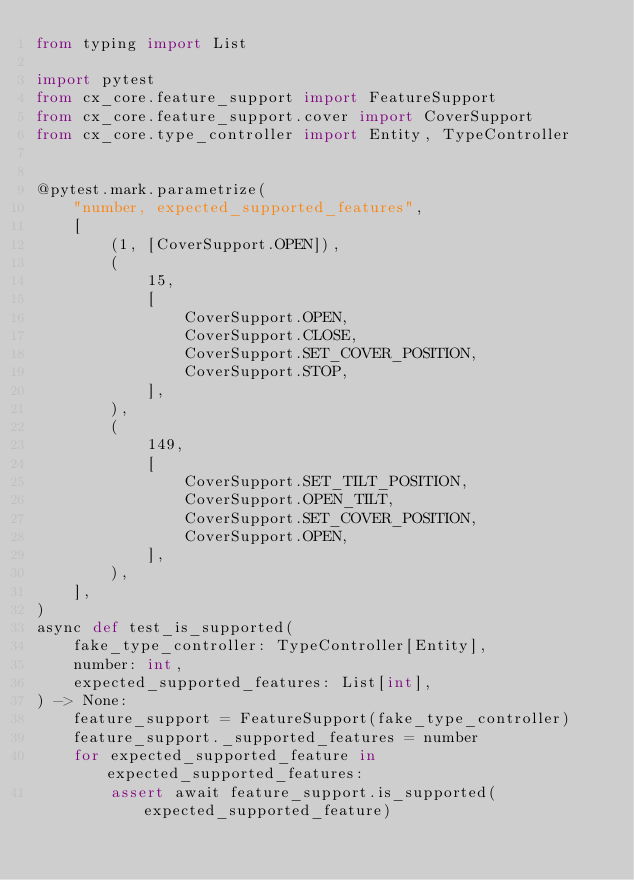<code> <loc_0><loc_0><loc_500><loc_500><_Python_>from typing import List

import pytest
from cx_core.feature_support import FeatureSupport
from cx_core.feature_support.cover import CoverSupport
from cx_core.type_controller import Entity, TypeController


@pytest.mark.parametrize(
    "number, expected_supported_features",
    [
        (1, [CoverSupport.OPEN]),
        (
            15,
            [
                CoverSupport.OPEN,
                CoverSupport.CLOSE,
                CoverSupport.SET_COVER_POSITION,
                CoverSupport.STOP,
            ],
        ),
        (
            149,
            [
                CoverSupport.SET_TILT_POSITION,
                CoverSupport.OPEN_TILT,
                CoverSupport.SET_COVER_POSITION,
                CoverSupport.OPEN,
            ],
        ),
    ],
)
async def test_is_supported(
    fake_type_controller: TypeController[Entity],
    number: int,
    expected_supported_features: List[int],
) -> None:
    feature_support = FeatureSupport(fake_type_controller)
    feature_support._supported_features = number
    for expected_supported_feature in expected_supported_features:
        assert await feature_support.is_supported(expected_supported_feature)
</code> 